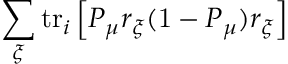Convert formula to latex. <formula><loc_0><loc_0><loc_500><loc_500>\sum _ { \xi } t r _ { i } \left [ P _ { \mu } r _ { \xi } ( 1 - P _ { \mu } ) r _ { \xi } \right ]</formula> 